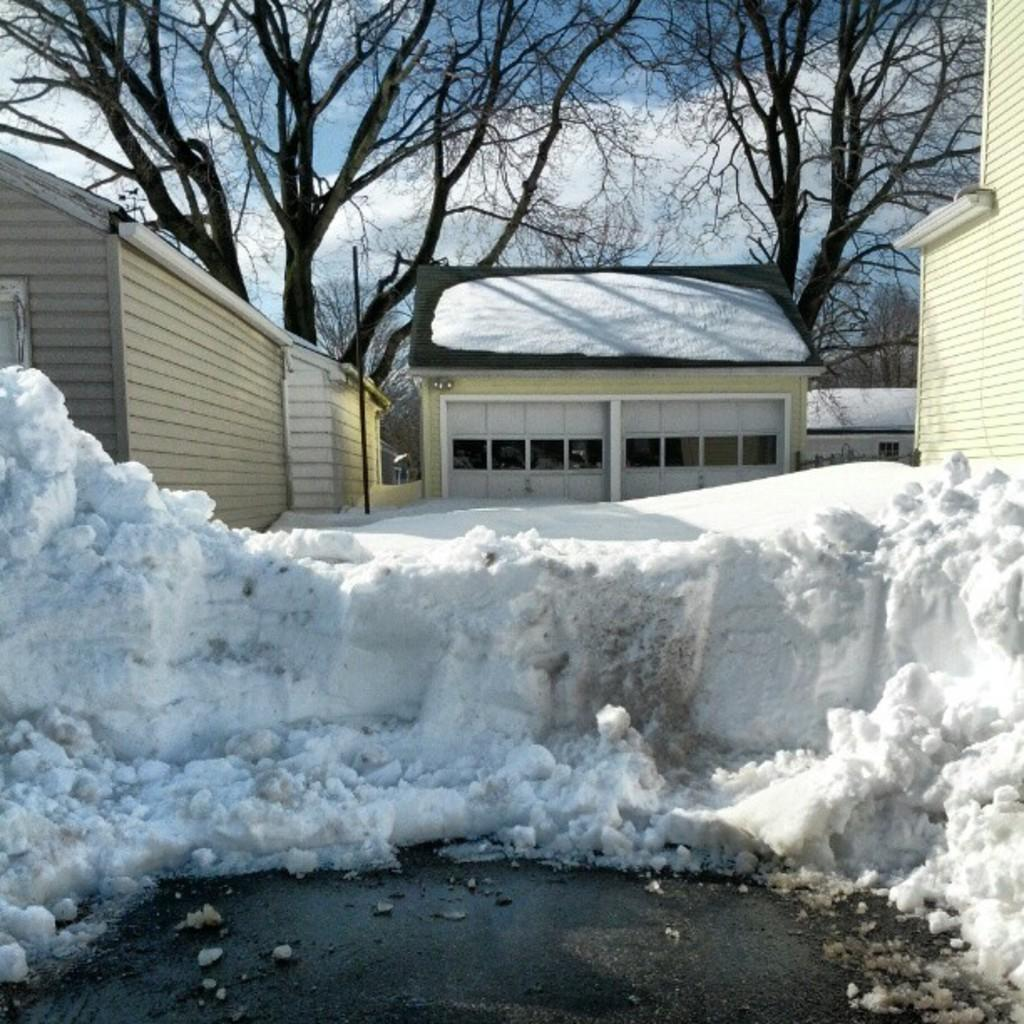What type of structures are present in the image? There are houses with windows in the image. What object can be seen standing upright in the image? There is a pole in the image. What is the weather like in the image? There is snow visible in the image, indicating a cold or wintry weather. What type of vegetation is present in the image? There are trees in the image. What can be seen in the background of the image? The sky with clouds is visible in the background of the image. What type of whistle can be heard in the image? There is no whistle present in the image, so no sound can be heard. What type of drum is being played in the image? There is no drum present in the image, so no drumming can be observed. 